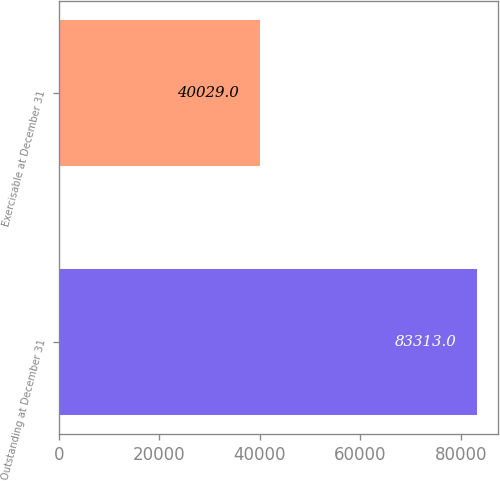Convert chart to OTSL. <chart><loc_0><loc_0><loc_500><loc_500><bar_chart><fcel>Outstanding at December 31<fcel>Exercisable at December 31<nl><fcel>83313<fcel>40029<nl></chart> 